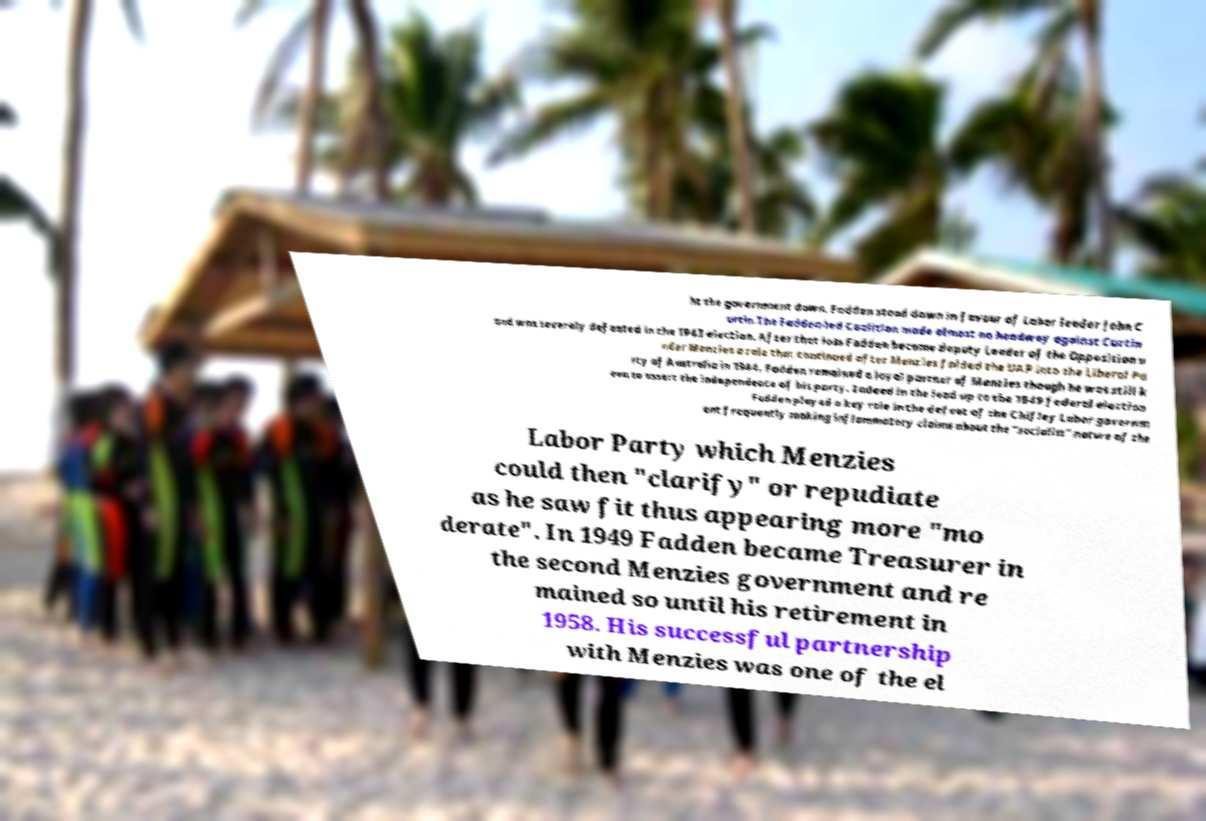Please identify and transcribe the text found in this image. ht the government down. Fadden stood down in favour of Labor leader John C urtin.The Fadden-led Coalition made almost no headway against Curtin and was severely defeated in the 1943 election. After that loss Fadden became deputy Leader of the Opposition u nder Menzies a role that continued after Menzies folded the UAP into the Liberal Pa rty of Australia in 1944. Fadden remained a loyal partner of Menzies though he was still k een to assert the independence of his party. Indeed in the lead up to the 1949 federal election Fadden played a key role in the defeat of the Chifley Labor governm ent frequently making inflammatory claims about the "socialist" nature of the Labor Party which Menzies could then "clarify" or repudiate as he saw fit thus appearing more "mo derate". In 1949 Fadden became Treasurer in the second Menzies government and re mained so until his retirement in 1958. His successful partnership with Menzies was one of the el 